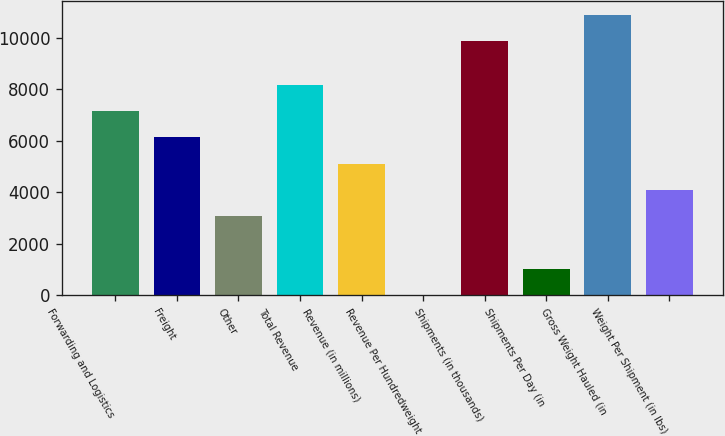<chart> <loc_0><loc_0><loc_500><loc_500><bar_chart><fcel>Forwarding and Logistics<fcel>Freight<fcel>Other<fcel>Total Revenue<fcel>Revenue (in millions)<fcel>Revenue Per Hundredweight<fcel>Shipments (in thousands)<fcel>Shipments Per Day (in<fcel>Gross Weight Hauled (in<fcel>Weight Per Shipment (in lbs)<nl><fcel>7153<fcel>6133.67<fcel>3075.68<fcel>8172.33<fcel>5114.34<fcel>17.69<fcel>9880<fcel>1037.02<fcel>10899.3<fcel>4095.01<nl></chart> 